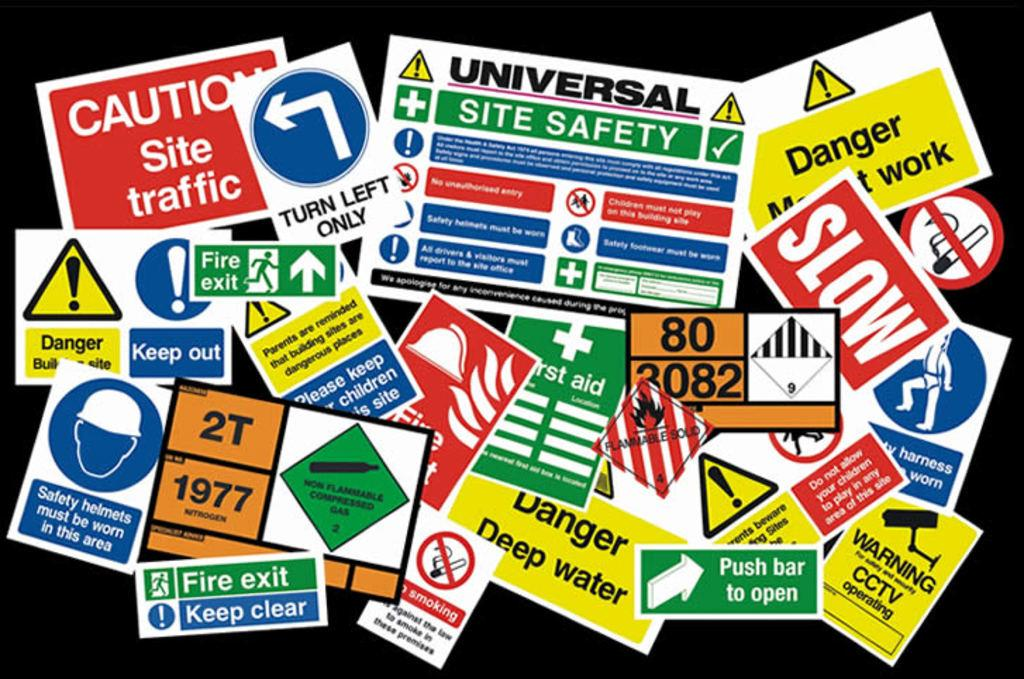<image>
Create a compact narrative representing the image presented. Many posters of caution, warning, and danger signs on a black background. 